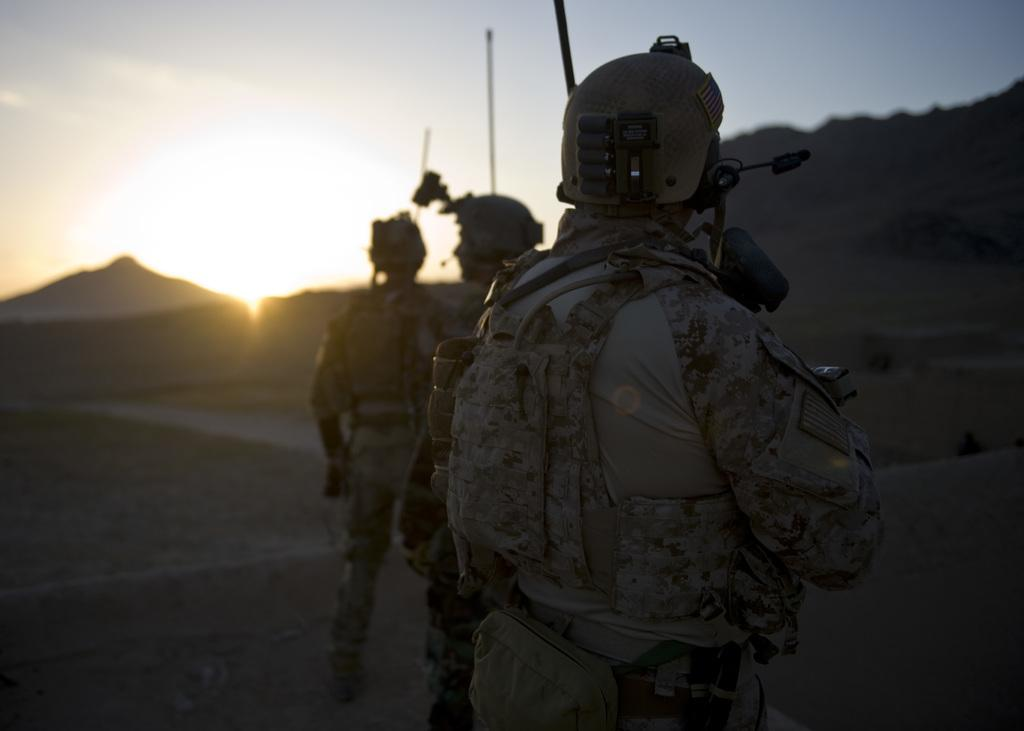How many people are in the image? There are three people in the image. What are the people standing on? The people are standing on the land. What are the people wearing on their heads? The people are wearing helmets. What can be seen in the background of the image? There are hills in the background of the image. What is visible at the top of the image? The sky is visible at the top of the image, and there is a sun visible in the sky. What type of plants are growing on the table in the image? There is no table or plants present in the image. How does the sun feel about the people in the image? The sun is a celestial body and does not have feelings or emotions. 